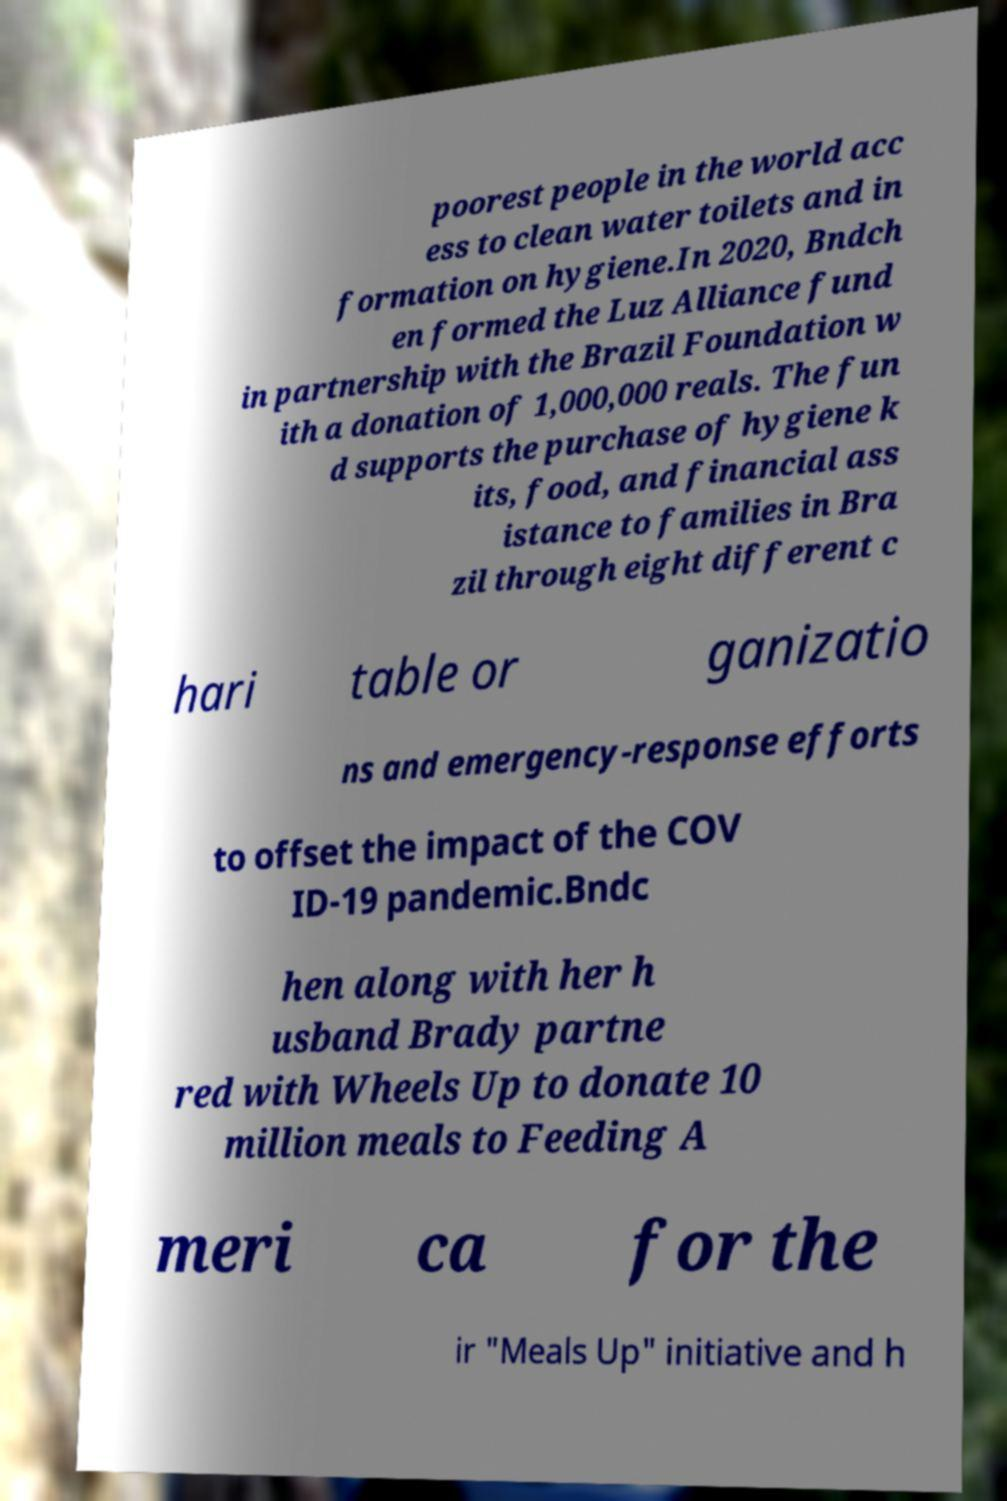I need the written content from this picture converted into text. Can you do that? poorest people in the world acc ess to clean water toilets and in formation on hygiene.In 2020, Bndch en formed the Luz Alliance fund in partnership with the Brazil Foundation w ith a donation of 1,000,000 reals. The fun d supports the purchase of hygiene k its, food, and financial ass istance to families in Bra zil through eight different c hari table or ganizatio ns and emergency-response efforts to offset the impact of the COV ID-19 pandemic.Bndc hen along with her h usband Brady partne red with Wheels Up to donate 10 million meals to Feeding A meri ca for the ir "Meals Up" initiative and h 